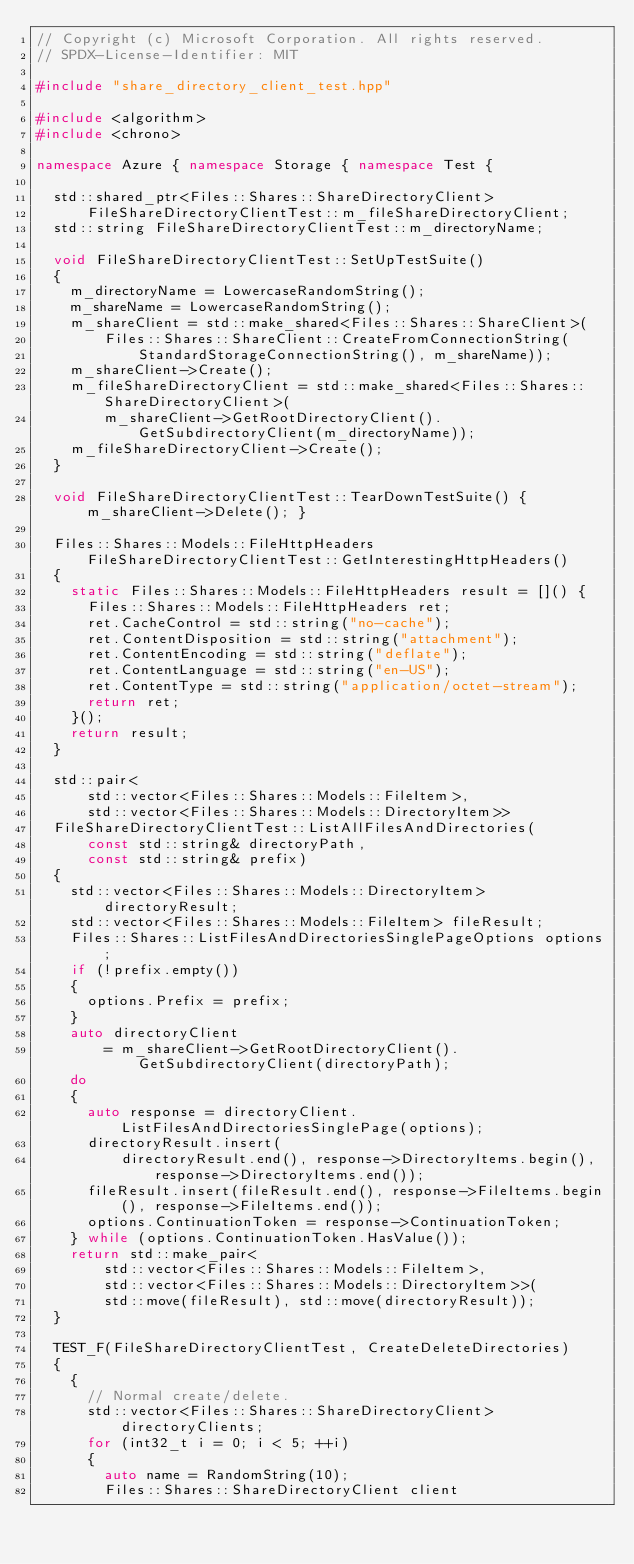<code> <loc_0><loc_0><loc_500><loc_500><_C++_>// Copyright (c) Microsoft Corporation. All rights reserved.
// SPDX-License-Identifier: MIT

#include "share_directory_client_test.hpp"

#include <algorithm>
#include <chrono>

namespace Azure { namespace Storage { namespace Test {

  std::shared_ptr<Files::Shares::ShareDirectoryClient>
      FileShareDirectoryClientTest::m_fileShareDirectoryClient;
  std::string FileShareDirectoryClientTest::m_directoryName;

  void FileShareDirectoryClientTest::SetUpTestSuite()
  {
    m_directoryName = LowercaseRandomString();
    m_shareName = LowercaseRandomString();
    m_shareClient = std::make_shared<Files::Shares::ShareClient>(
        Files::Shares::ShareClient::CreateFromConnectionString(
            StandardStorageConnectionString(), m_shareName));
    m_shareClient->Create();
    m_fileShareDirectoryClient = std::make_shared<Files::Shares::ShareDirectoryClient>(
        m_shareClient->GetRootDirectoryClient().GetSubdirectoryClient(m_directoryName));
    m_fileShareDirectoryClient->Create();
  }

  void FileShareDirectoryClientTest::TearDownTestSuite() { m_shareClient->Delete(); }

  Files::Shares::Models::FileHttpHeaders FileShareDirectoryClientTest::GetInterestingHttpHeaders()
  {
    static Files::Shares::Models::FileHttpHeaders result = []() {
      Files::Shares::Models::FileHttpHeaders ret;
      ret.CacheControl = std::string("no-cache");
      ret.ContentDisposition = std::string("attachment");
      ret.ContentEncoding = std::string("deflate");
      ret.ContentLanguage = std::string("en-US");
      ret.ContentType = std::string("application/octet-stream");
      return ret;
    }();
    return result;
  }

  std::pair<
      std::vector<Files::Shares::Models::FileItem>,
      std::vector<Files::Shares::Models::DirectoryItem>>
  FileShareDirectoryClientTest::ListAllFilesAndDirectories(
      const std::string& directoryPath,
      const std::string& prefix)
  {
    std::vector<Files::Shares::Models::DirectoryItem> directoryResult;
    std::vector<Files::Shares::Models::FileItem> fileResult;
    Files::Shares::ListFilesAndDirectoriesSinglePageOptions options;
    if (!prefix.empty())
    {
      options.Prefix = prefix;
    }
    auto directoryClient
        = m_shareClient->GetRootDirectoryClient().GetSubdirectoryClient(directoryPath);
    do
    {
      auto response = directoryClient.ListFilesAndDirectoriesSinglePage(options);
      directoryResult.insert(
          directoryResult.end(), response->DirectoryItems.begin(), response->DirectoryItems.end());
      fileResult.insert(fileResult.end(), response->FileItems.begin(), response->FileItems.end());
      options.ContinuationToken = response->ContinuationToken;
    } while (options.ContinuationToken.HasValue());
    return std::make_pair<
        std::vector<Files::Shares::Models::FileItem>,
        std::vector<Files::Shares::Models::DirectoryItem>>(
        std::move(fileResult), std::move(directoryResult));
  }

  TEST_F(FileShareDirectoryClientTest, CreateDeleteDirectories)
  {
    {
      // Normal create/delete.
      std::vector<Files::Shares::ShareDirectoryClient> directoryClients;
      for (int32_t i = 0; i < 5; ++i)
      {
        auto name = RandomString(10);
        Files::Shares::ShareDirectoryClient client</code> 